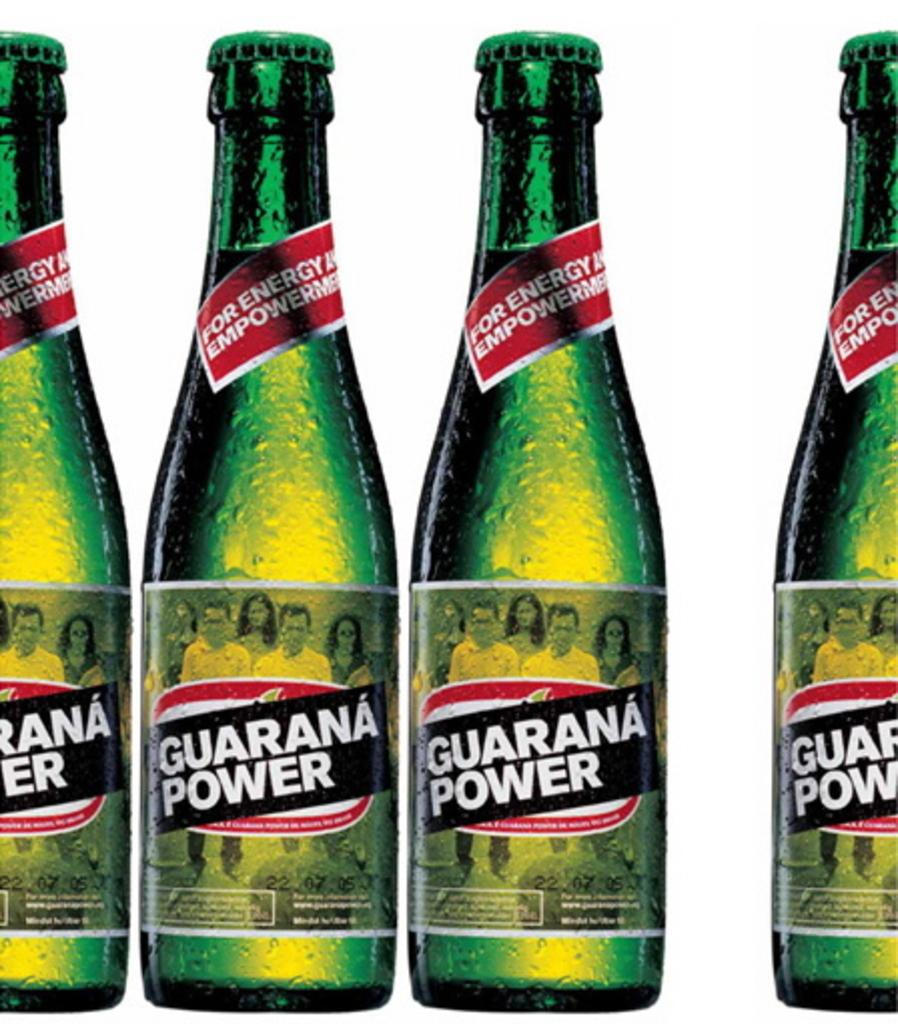<image>
Provide a brief description of the given image. An advertisement for a green bottle drink that says Guarana Power on the label 